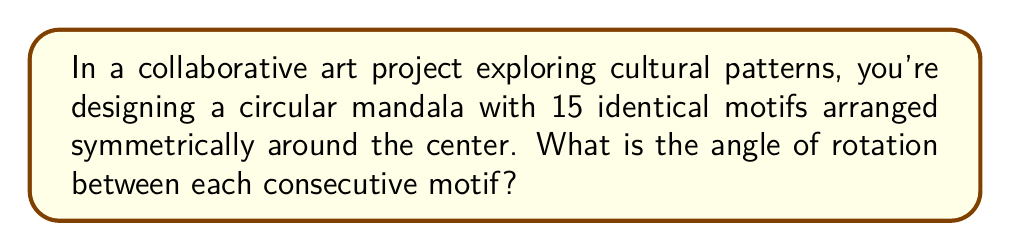Give your solution to this math problem. To solve this problem, we need to follow these steps:

1) In a complete circle, there are 360°.

2) The motifs are arranged symmetrically, which means they are evenly spaced around the circle.

3) There are 15 identical motifs.

4) To find the angle between each motif, we need to divide the total degrees in a circle by the number of motifs:

   $$\text{Angle of rotation} = \frac{\text{Total degrees in a circle}}{\text{Number of motifs}}$$

   $$\text{Angle of rotation} = \frac{360°}{15}$$

5) Simplify the fraction:

   $$\text{Angle of rotation} = 24°$$

Therefore, each motif is rotated 24° from the previous one to create the symmetrical pattern.

[asy]
unitsize(2cm);
draw(circle((0,0),1));
for(int i=0; i<15; ++i) {
  draw((0,0)--dir(i*24),(0.95,1),Arrow);
}
label("24°", (0.7,0.3));
[/asy]
Answer: 24° 